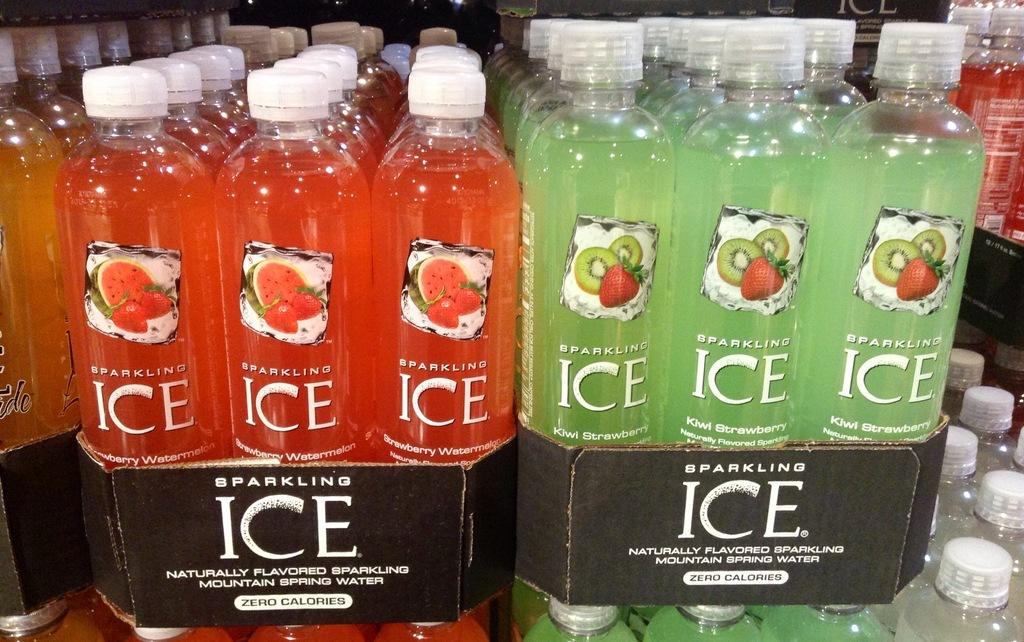<image>
Create a compact narrative representing the image presented. Bottles of two different flavors of Sparkling Ice stacked togehter 